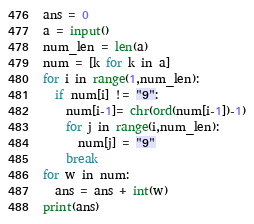<code> <loc_0><loc_0><loc_500><loc_500><_Python_>ans = 0
a = input()
num_len = len(a)
num = [k for k in a]
for i in range(1,num_len):
  if num[i] != "9":
    num[i-1]= chr(ord(num[i-1])-1)
    for j in range(i,num_len):
      num[j] = "9"
    break
for w in num:
  ans = ans + int(w)
print(ans)</code> 